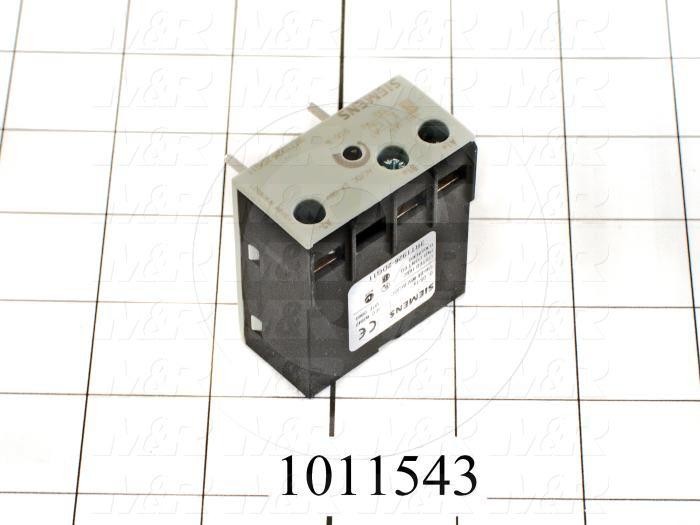What safety features might this electrical component have to ensure reliable operation? The electrical component appears to have several safety features to ensure reliable operation. Firstly, the labeling and certifications (such as the CE mark) imply compliance with safety and performance standards. It likely incorporates insulating materials to prevent short circuits and minimize the risk of electric shocks. The component's casing seems robust, which may protect the internal contacts from dust, moisture, and mechanical damage. Additionally, the terminal screws and connectors are designed to ensure secure and stable electrical connections, reducing the risk of sparking or overheating. These features collectively make the component reliable and safe for the intended applications. Could this component be used in an outdoor setting? While it's possible to use this component in an outdoor setting, it would typically require additional protective measures. The component itself does not appear to have specific weatherproofing or ruggedized features that you would expect for outdoor use. However, it could be housed within a weatherproof enclosure or electrical box that provides protection from the elements, such as rain, dust, and extreme temperatures. This would help ensure that the component remains operational and safe when used in an outdoor environment. Imagine a futuristic city where these components are integrated into a smart grid. What role might they play? In a futuristic city integrated with a smart grid, these components could play an essential role in the efficient distribution and control of electricity. They might be part of intelligent panels that automate the switching of electrical circuits based on real-time demand and supply conditions. For instance, during peak hours, these components could help manage load distribution by temporarily cutting power to non-essential systems. They could also be part of a system that integrates renewable energy sources, such as solar panels and wind turbines, dynamically routing power where it’s needed most. Additionally, they might facilitate the connection of smart appliances, electric vehicle charging stations, and energy storage solutions, ensuring seamless and efficient energy management across the city. Their ability to handle moderate currents makes them ideal for widespread deployment in numerous lower-power applications, contributing to the overall smart grid infrastructure.  What would be a typical scenario where this component plays a critical role in a small business? In a small business setting, this electrical component could be critical in managing the electrical supply to essential equipment. For instance, in a small bakery, it might control the power to various ovens and mixers, ensuring that they receive a steady and reliable current for consistent operation. The component could also be part of a backup power system, automatically switching to a generator in case of a power outage, thus ensuring business continuity. Additionally, in an office, it could manage the lighting circuits and heating systems to maintain a comfortable working environment. Its moderate current rating makes it suitable for controlling equipment that doesn't require heavy industrial power but is crucial for daily operations. 